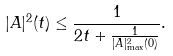<formula> <loc_0><loc_0><loc_500><loc_500>| A | ^ { 2 } ( t ) \leq \frac { 1 } { 2 t + \frac { 1 } { | A | ^ { 2 } _ { \max } ( 0 ) } } .</formula> 